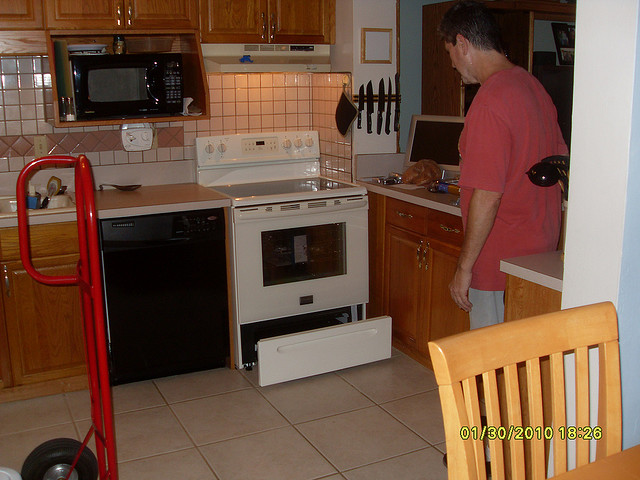Read and extract the text from this image. 01/30/2010 18:26 